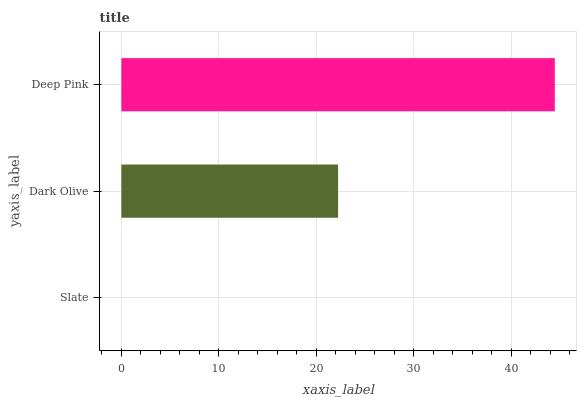Is Slate the minimum?
Answer yes or no. Yes. Is Deep Pink the maximum?
Answer yes or no. Yes. Is Dark Olive the minimum?
Answer yes or no. No. Is Dark Olive the maximum?
Answer yes or no. No. Is Dark Olive greater than Slate?
Answer yes or no. Yes. Is Slate less than Dark Olive?
Answer yes or no. Yes. Is Slate greater than Dark Olive?
Answer yes or no. No. Is Dark Olive less than Slate?
Answer yes or no. No. Is Dark Olive the high median?
Answer yes or no. Yes. Is Dark Olive the low median?
Answer yes or no. Yes. Is Slate the high median?
Answer yes or no. No. Is Slate the low median?
Answer yes or no. No. 